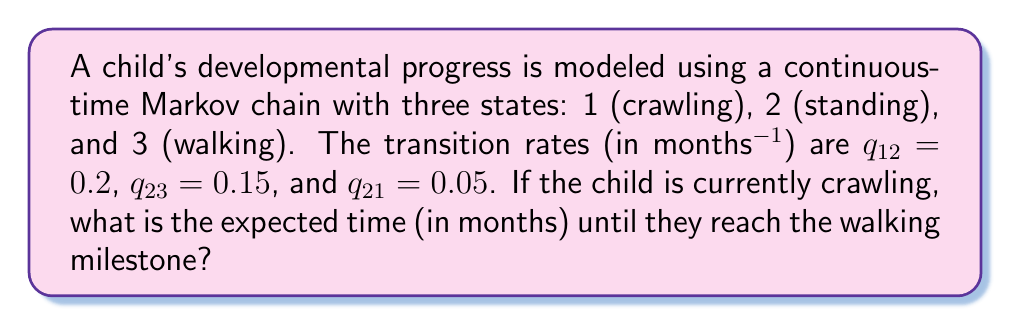Help me with this question. To solve this problem, we'll use the concept of mean first passage times in continuous-time Markov chains.

Step 1: Define the mean first passage times:
Let $m_{ij}$ be the mean time to reach state j starting from state i.
We need to find $m_{13}$.

Step 2: Set up the system of equations:
$$m_{13} = \frac{1}{q_{12}} + m_{23}$$
$$m_{23} = \frac{1}{q_{23} + q_{21}} + \frac{q_{21}}{q_{23} + q_{21}}m_{13}$$

Step 3: Substitute the given transition rates:
$$m_{13} = \frac{1}{0.2} + m_{23}$$
$$m_{23} = \frac{1}{0.15 + 0.05} + \frac{0.05}{0.15 + 0.05}m_{13}$$

Step 4: Simplify:
$$m_{13} = 5 + m_{23}$$
$$m_{23} = 5 + 0.25m_{13}$$

Step 5: Substitute the second equation into the first:
$$m_{13} = 5 + (5 + 0.25m_{13})$$
$$m_{13} = 10 + 0.25m_{13}$$

Step 6: Solve for $m_{13}$:
$$0.75m_{13} = 10$$
$$m_{13} = \frac{10}{0.75} = \frac{40}{3}$$

Therefore, the expected time until the child reaches the walking milestone is $\frac{40}{3}$ months.
Answer: $\frac{40}{3}$ months 